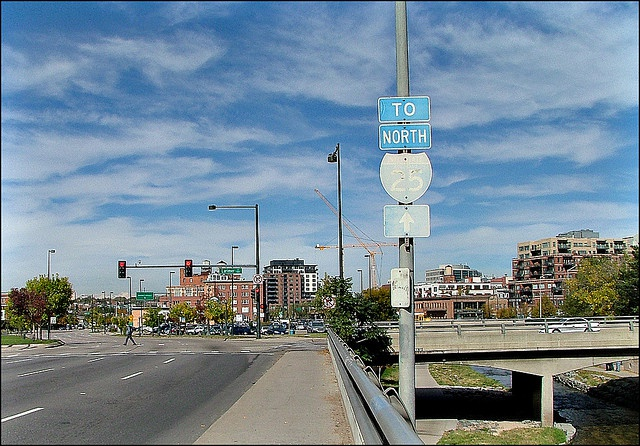Describe the objects in this image and their specific colors. I can see car in black, white, darkgray, and gray tones, people in black, darkgray, gray, and lightgray tones, car in black, gray, navy, and darkgray tones, car in black, gray, darkgray, and lightgray tones, and car in black, gray, darkgray, and navy tones in this image. 